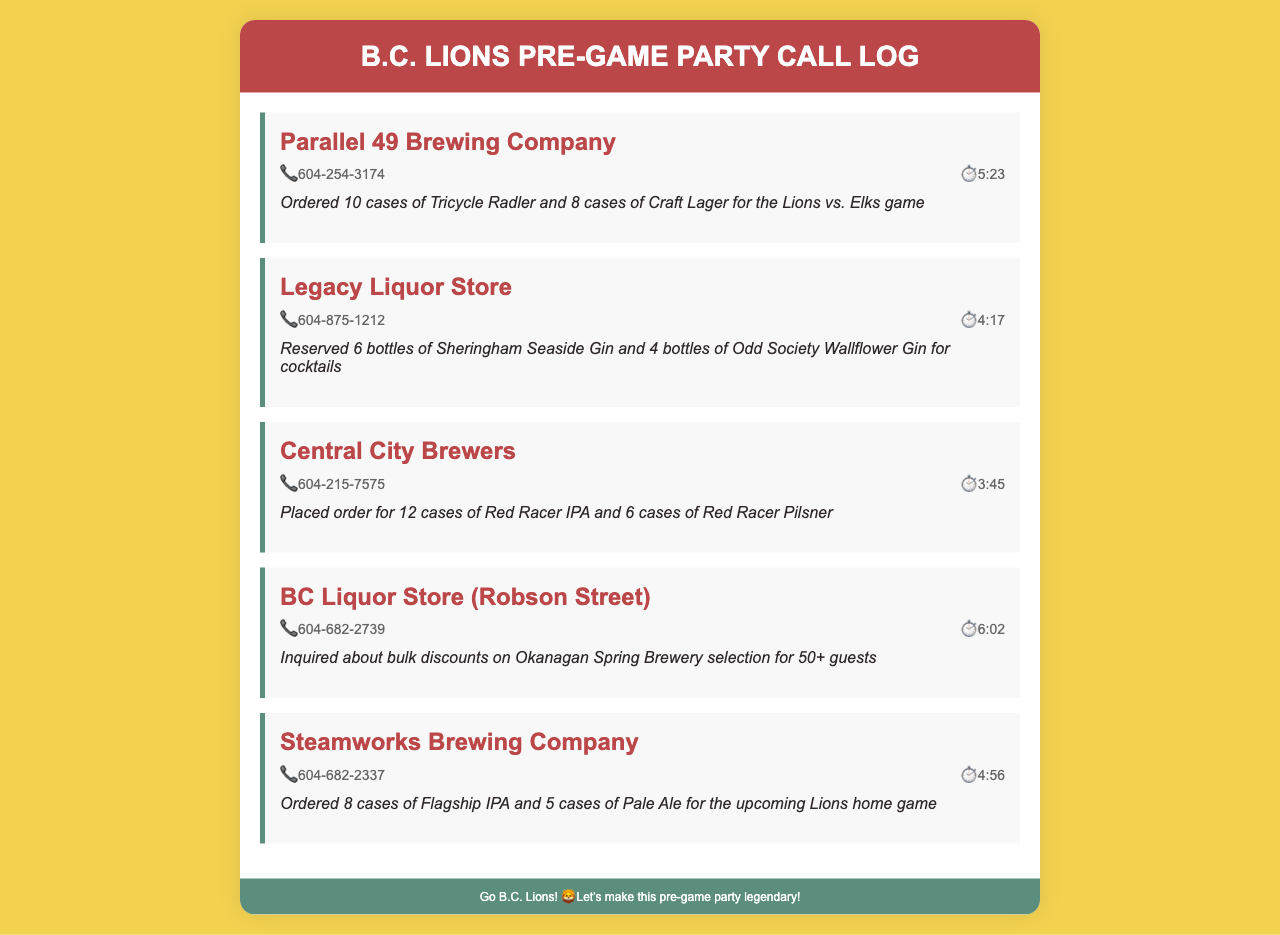What is the phone number for Parallel 49 Brewing Company? The phone number is listed in the call entry for Parallel 49 Brewing Company.
Answer: 604-254-3174 How many cases of Red Racer IPA were ordered? The document specifies the order details for Central City Brewers, which includes the number of cases.
Answer: 12 cases What type of gin was reserved at Legacy Liquor Store? This information can be found within the notes of the Legacy Liquor Store entry.
Answer: Sheringham Seaside Gin How long was the call made to BC Liquor Store (Robson Street)? The duration of the call is noted in the call details for that entry.
Answer: 6:02 Which brewery provided Flagship IPA? The specific brewery name is included in the call entry for the order made.
Answer: Steamworks Brewing Company What was inquired about during the call to BC Liquor Store? The notes provide details about the inquiry made during the call.
Answer: bulk discounts How many cases of Craft Lager were ordered from Parallel 49 Brewing Company? The specific order details, including the number of cases, are in the notes.
Answer: 8 cases What is the reason for the call to Central City Brewers? The call entry has notes that explain the purpose of the call.
Answer: Placed order How many bottles of Odd Society Wallflower Gin were reserved? The document lists the number of bottles in the Legacy Liquor Store entry.
Answer: 4 bottles 